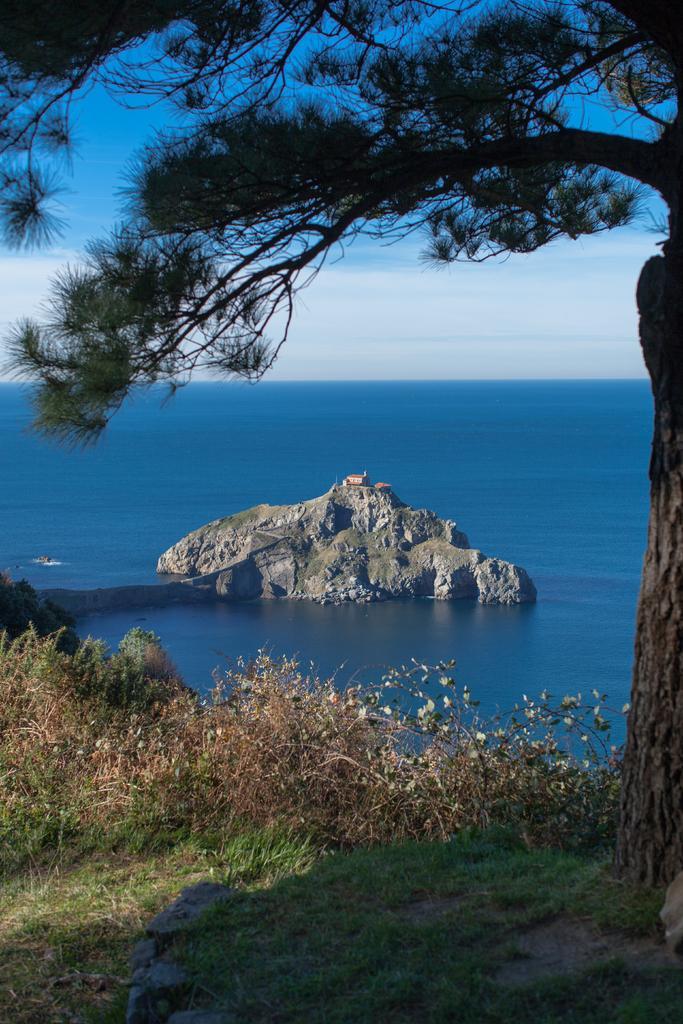Please provide a concise description of this image. In the center of the image we can see a mountain, house. In the background of the image we can see the water. On the right side of the image we can see a tree. At the bottom of the image we can see some plants, grass and ground. At the top of the image we can see the clouds are present in the sky. 